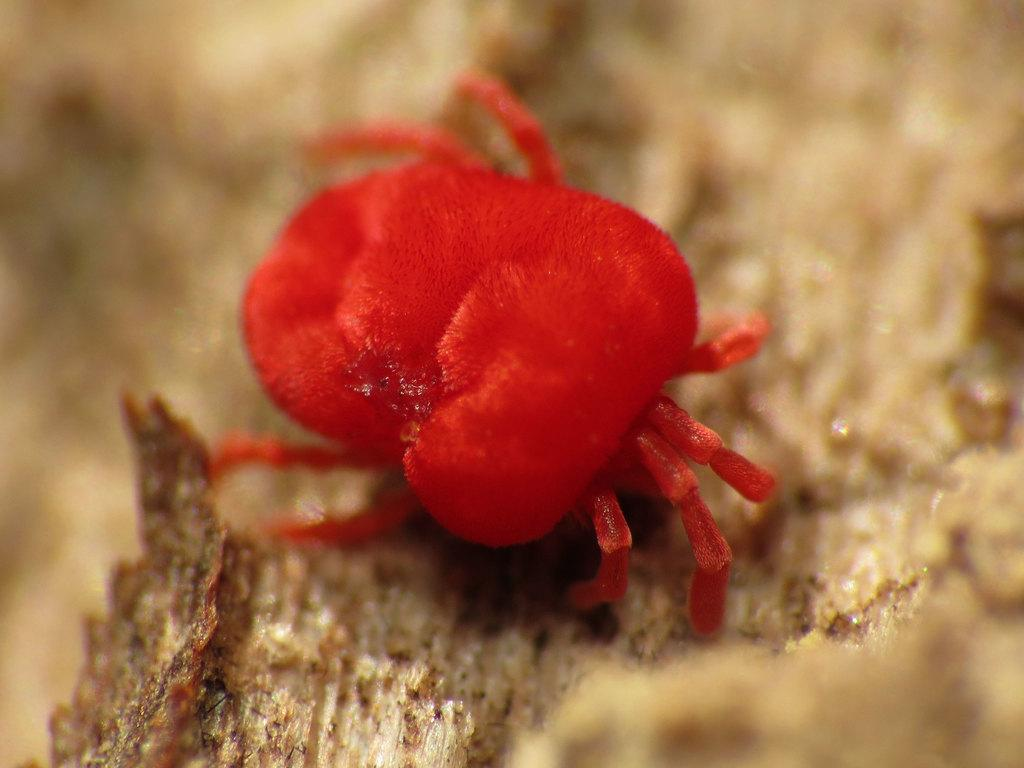What type of insect is in the picture? There is a red color insect in the picture. Where is the insect located? The insect is on a platform. Can you describe the background of the image? The background of the image is blurry. What type of sign can be seen in the image? There is no sign present in the image; it only features a red color insect on a platform with a blurry background. 